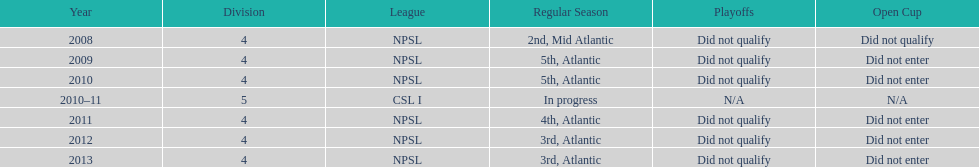How did they place the year after they were 4th in the regular season? 3rd. 